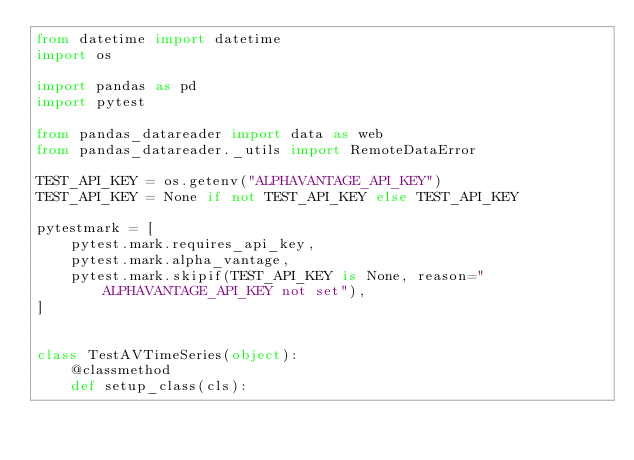<code> <loc_0><loc_0><loc_500><loc_500><_Python_>from datetime import datetime
import os

import pandas as pd
import pytest

from pandas_datareader import data as web
from pandas_datareader._utils import RemoteDataError

TEST_API_KEY = os.getenv("ALPHAVANTAGE_API_KEY")
TEST_API_KEY = None if not TEST_API_KEY else TEST_API_KEY

pytestmark = [
    pytest.mark.requires_api_key,
    pytest.mark.alpha_vantage,
    pytest.mark.skipif(TEST_API_KEY is None, reason="ALPHAVANTAGE_API_KEY not set"),
]


class TestAVTimeSeries(object):
    @classmethod
    def setup_class(cls):</code> 